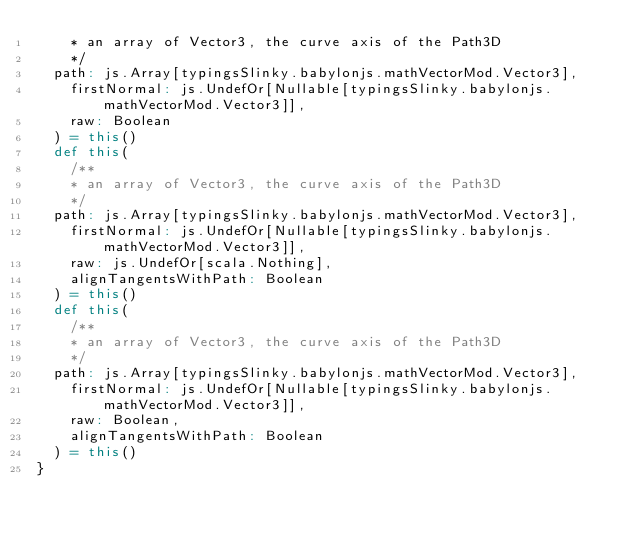Convert code to text. <code><loc_0><loc_0><loc_500><loc_500><_Scala_>    * an array of Vector3, the curve axis of the Path3D
    */
  path: js.Array[typingsSlinky.babylonjs.mathVectorMod.Vector3],
    firstNormal: js.UndefOr[Nullable[typingsSlinky.babylonjs.mathVectorMod.Vector3]],
    raw: Boolean
  ) = this()
  def this(
    /**
    * an array of Vector3, the curve axis of the Path3D
    */
  path: js.Array[typingsSlinky.babylonjs.mathVectorMod.Vector3],
    firstNormal: js.UndefOr[Nullable[typingsSlinky.babylonjs.mathVectorMod.Vector3]],
    raw: js.UndefOr[scala.Nothing],
    alignTangentsWithPath: Boolean
  ) = this()
  def this(
    /**
    * an array of Vector3, the curve axis of the Path3D
    */
  path: js.Array[typingsSlinky.babylonjs.mathVectorMod.Vector3],
    firstNormal: js.UndefOr[Nullable[typingsSlinky.babylonjs.mathVectorMod.Vector3]],
    raw: Boolean,
    alignTangentsWithPath: Boolean
  ) = this()
}
</code> 